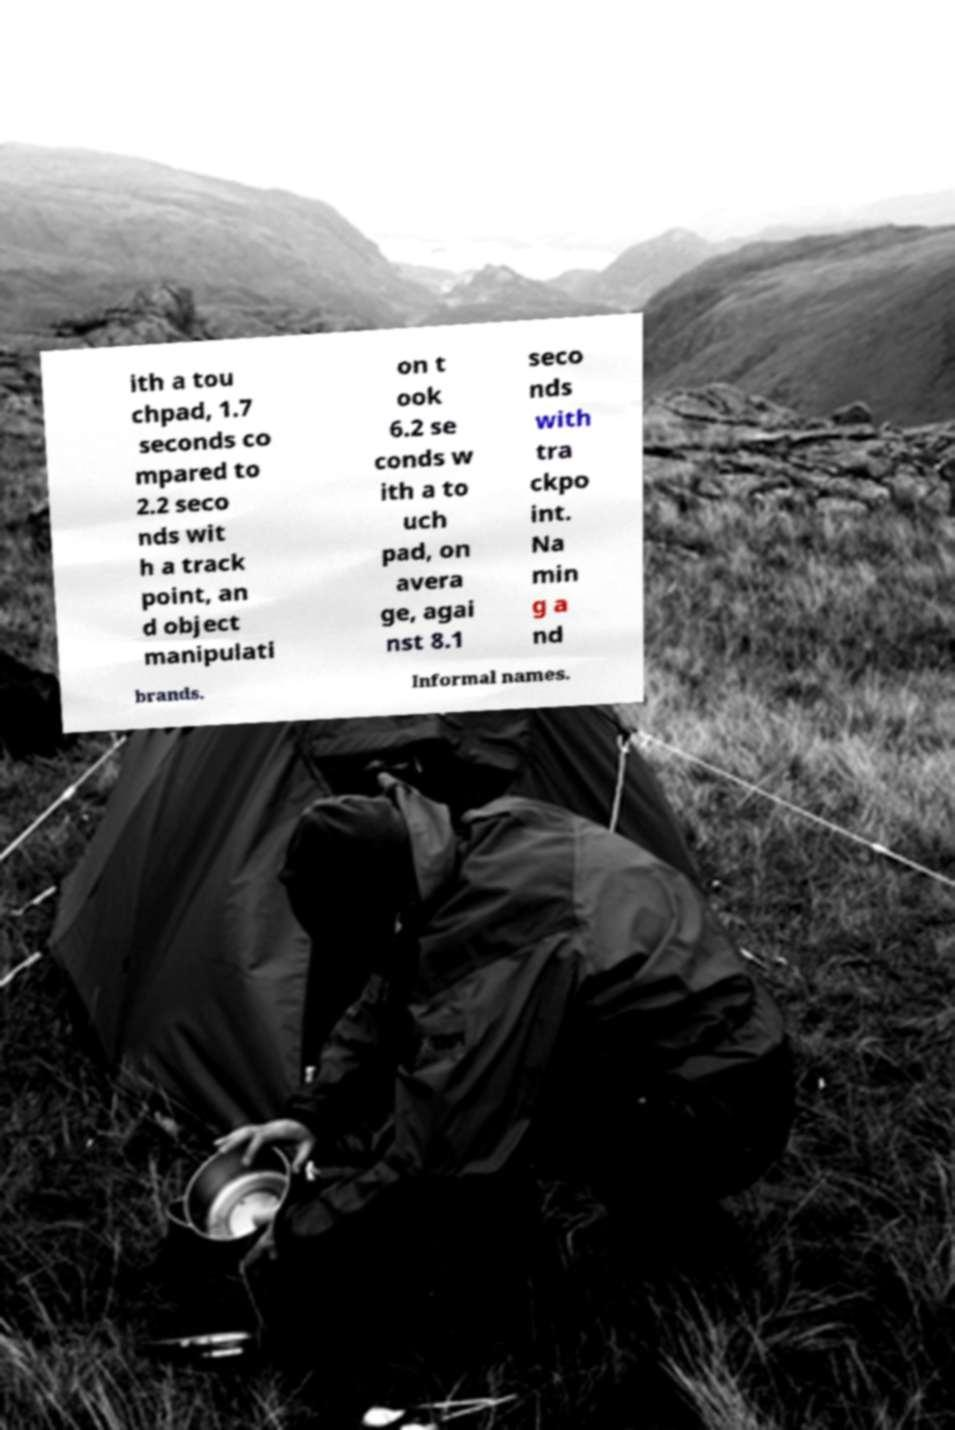Can you read and provide the text displayed in the image?This photo seems to have some interesting text. Can you extract and type it out for me? ith a tou chpad, 1.7 seconds co mpared to 2.2 seco nds wit h a track point, an d object manipulati on t ook 6.2 se conds w ith a to uch pad, on avera ge, agai nst 8.1 seco nds with tra ckpo int. Na min g a nd brands. Informal names. 